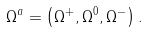<formula> <loc_0><loc_0><loc_500><loc_500>\Omega ^ { a } = \left ( \Omega ^ { + } , \Omega ^ { 0 } , \Omega ^ { - } \right ) .</formula> 